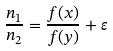Convert formula to latex. <formula><loc_0><loc_0><loc_500><loc_500>\frac { n _ { 1 } } { n _ { 2 } } = \frac { f ( x ) } { f ( y ) } + \varepsilon</formula> 